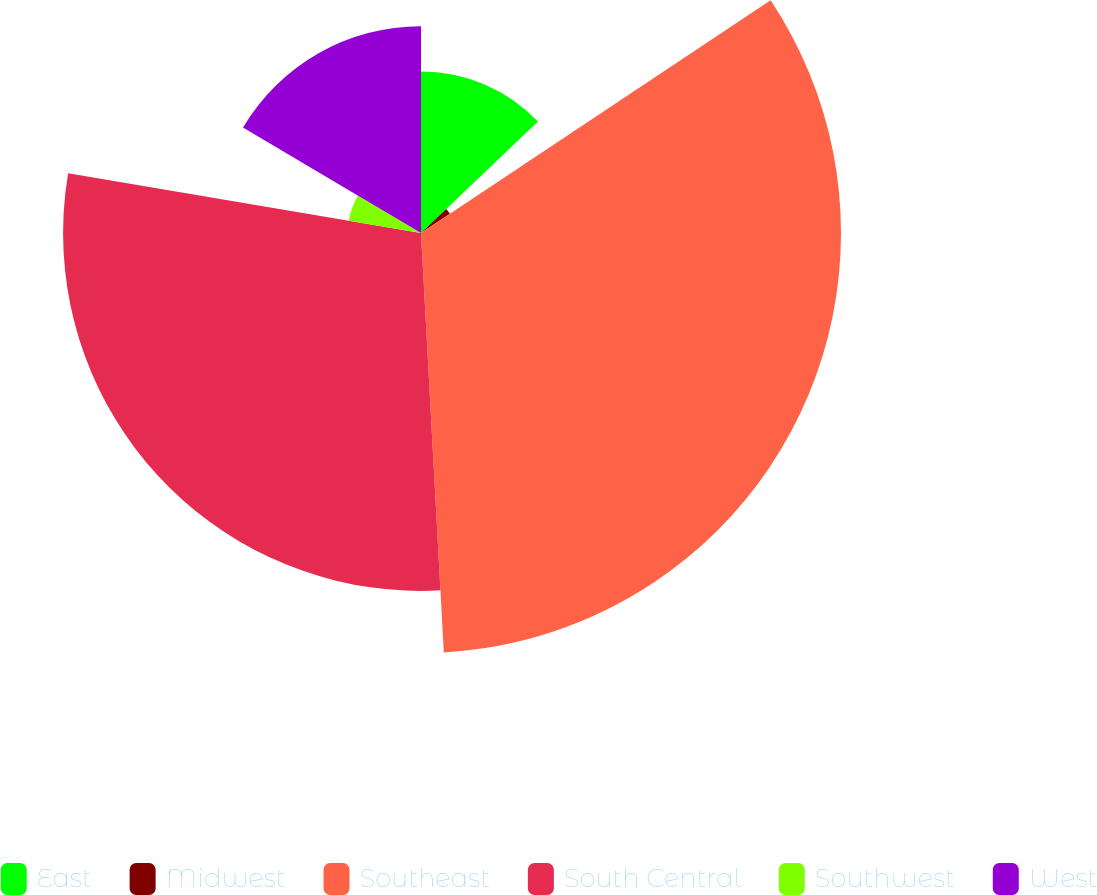<chart> <loc_0><loc_0><loc_500><loc_500><pie_chart><fcel>East<fcel>Midwest<fcel>Southeast<fcel>South Central<fcel>Southwest<fcel>West<nl><fcel>12.88%<fcel>2.77%<fcel>33.48%<fcel>28.53%<fcel>5.84%<fcel>16.49%<nl></chart> 